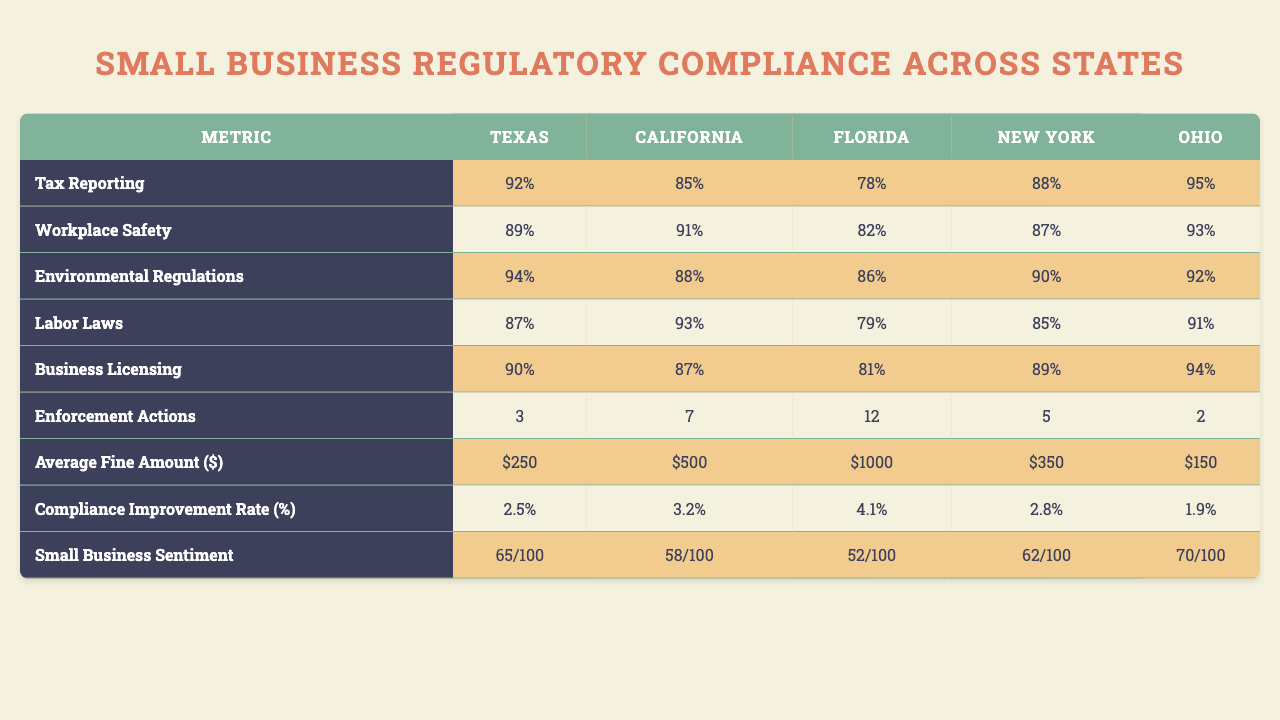What is the compliance rate for Tax Reporting in Texas? The table shows the compliance rates for various regulatory requirements in different states. For Tax Reporting in Texas, the compliance rate is listed as 92%.
Answer: 92% What small business has the highest compliance rate for Workplace Safety? The table displays the compliance rates for Workplace Safety across small businesses. Green Valley Farm has the highest compliance rate at 88%.
Answer: Green Valley Farm Which state has the lowest compliance rate for Labor Laws? Looking across the compliance rates for Labor Laws, New York has the lowest compliance rate at 79%.
Answer: New York What is the total number of enforcement actions for Tech Solutions Inc.? To find the total enforcement actions for Tech Solutions Inc., we refer to the corresponding row in the table. The total enforcement actions listed for Tech Solutions Inc. in the table is 4, 5, 10, 5, and 2, which sums to 26.
Answer: 26 What is the average compliance rate for small businesses in California across all regulatory requirements? The table shows the compliance rates for different regulatory requirements in California: 89%, 91%, 82%, 87%, and 93%. The average is calculated by summing these rates (89 + 91 + 82 + 87 + 93 = 442) and dividing by the number of requirements (442/5 = 88.4).
Answer: 88.4% Is the average fine amount for Environmental Regulations across all states above $400? The average fine amounts for Environmental Regulations are $1000, $850, $950, $1100, and $900. The average is calculated as (1000 + 850 + 950 + 1100 + 900 = 4750), resulting in an average of 4750/5 = 950 which is above $400.
Answer: Yes Which state exhibits the highest small business sentiment on average? The table shows sentiment scores for each state. Texas: 65, California: 62, Florida: 67, New York: 60, and Ohio: 63. The highest sentiment score is 67 for Florida.
Answer: Florida Compare the compliance improvement rate for Labor Laws in New York versus Texas. Which is higher? The compliance improvement rates for Labor Laws are 3.3% for New York and 2.8% for Texas. To compare, New York's rate (3.3%) is higher than Texas' (2.8%).
Answer: New York What is the difference between the highest and lowest average fine amounts for Business Licensing across states? The average fine amounts for Business Licensing are $150, $200, $175, $225, and $180. The highest is $225 (New York) and the lowest is $150 (Texas). The difference is calculated as $225 - $150 = $75.
Answer: $75 What is the compliance rate for Environmental Regulations in Florida? Referring to the table, for Environmental Regulations in Florida, the compliance rate is 82%.
Answer: 82% Has Joe's Auto Repair improved its compliance rate for Labor Laws from the previous year? The compliance improvement rate for Labor Laws for Joe's Auto Repair is 2.5%. This indicates an improvement as the rate increased.
Answer: Yes 